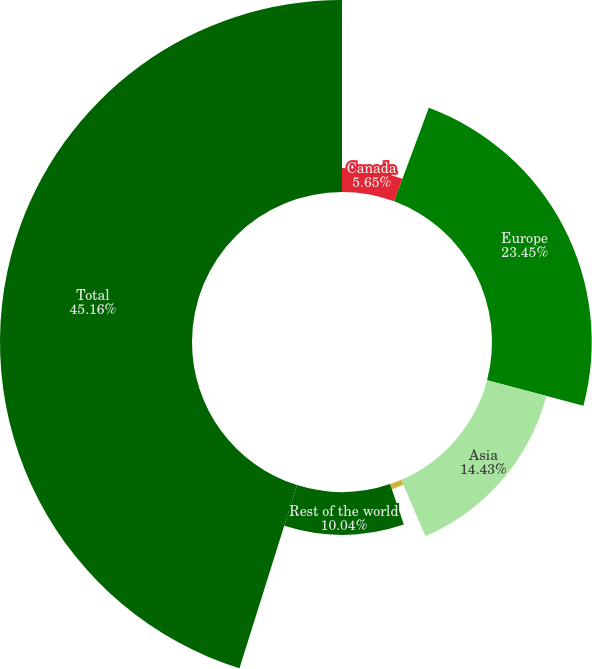<chart> <loc_0><loc_0><loc_500><loc_500><pie_chart><fcel>Canada<fcel>Europe<fcel>Asia<fcel>Middle East<fcel>Rest of the world<fcel>Total<nl><fcel>5.65%<fcel>23.45%<fcel>14.43%<fcel>1.27%<fcel>10.04%<fcel>45.15%<nl></chart> 